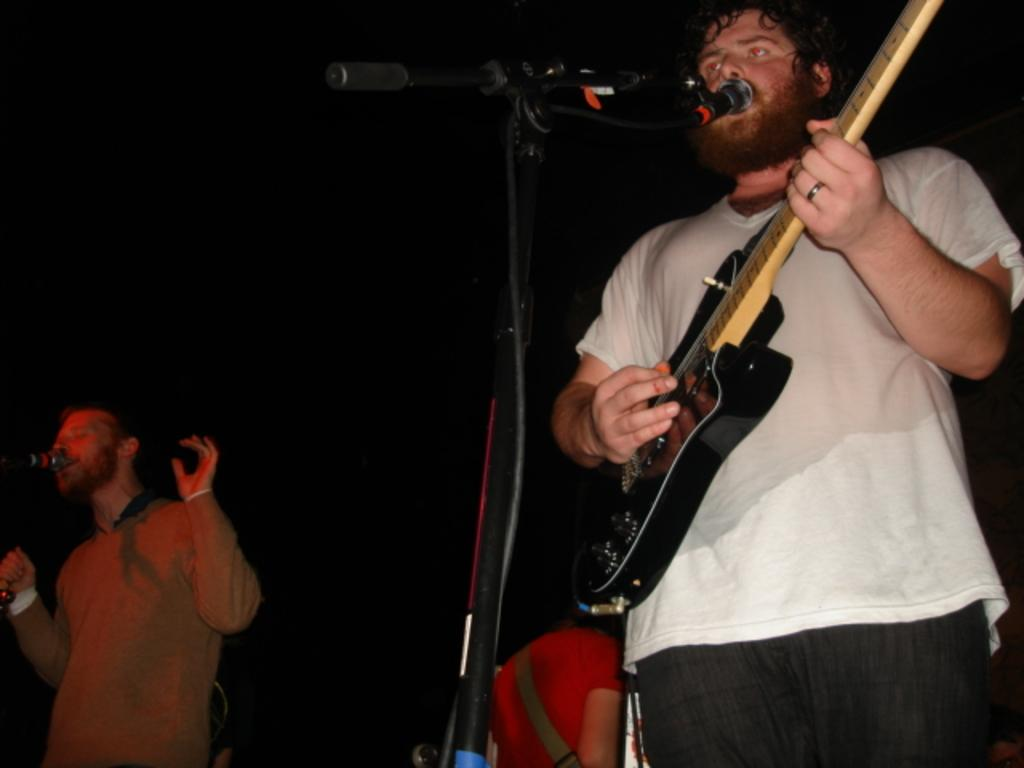How many people are in the image? There are two men in the image. What are the men doing in the image? The men are standing in front of a microphone. What instrument is one of the men playing? One of the men is playing a guitar. What type of dinosaurs can be seen in the image? There are no dinosaurs present in the image. 